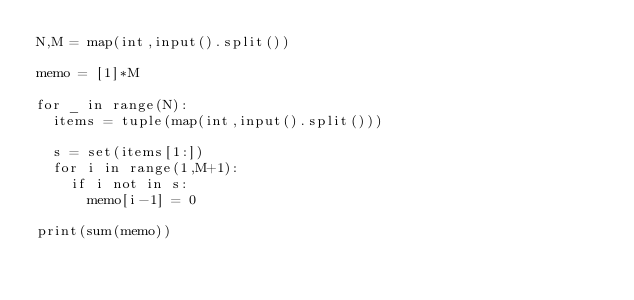Convert code to text. <code><loc_0><loc_0><loc_500><loc_500><_Python_>N,M = map(int,input().split())

memo = [1]*M

for _ in range(N):
  items = tuple(map(int,input().split()))
  
  s = set(items[1:])
  for i in range(1,M+1):
    if i not in s:
      memo[i-1] = 0

print(sum(memo))
</code> 